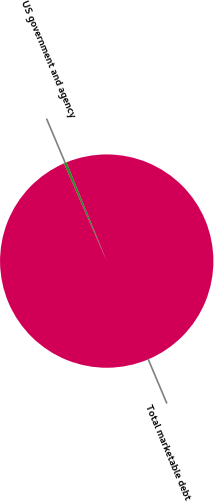Convert chart. <chart><loc_0><loc_0><loc_500><loc_500><pie_chart><fcel>US government and agency<fcel>Total marketable debt<nl><fcel>0.43%<fcel>99.57%<nl></chart> 